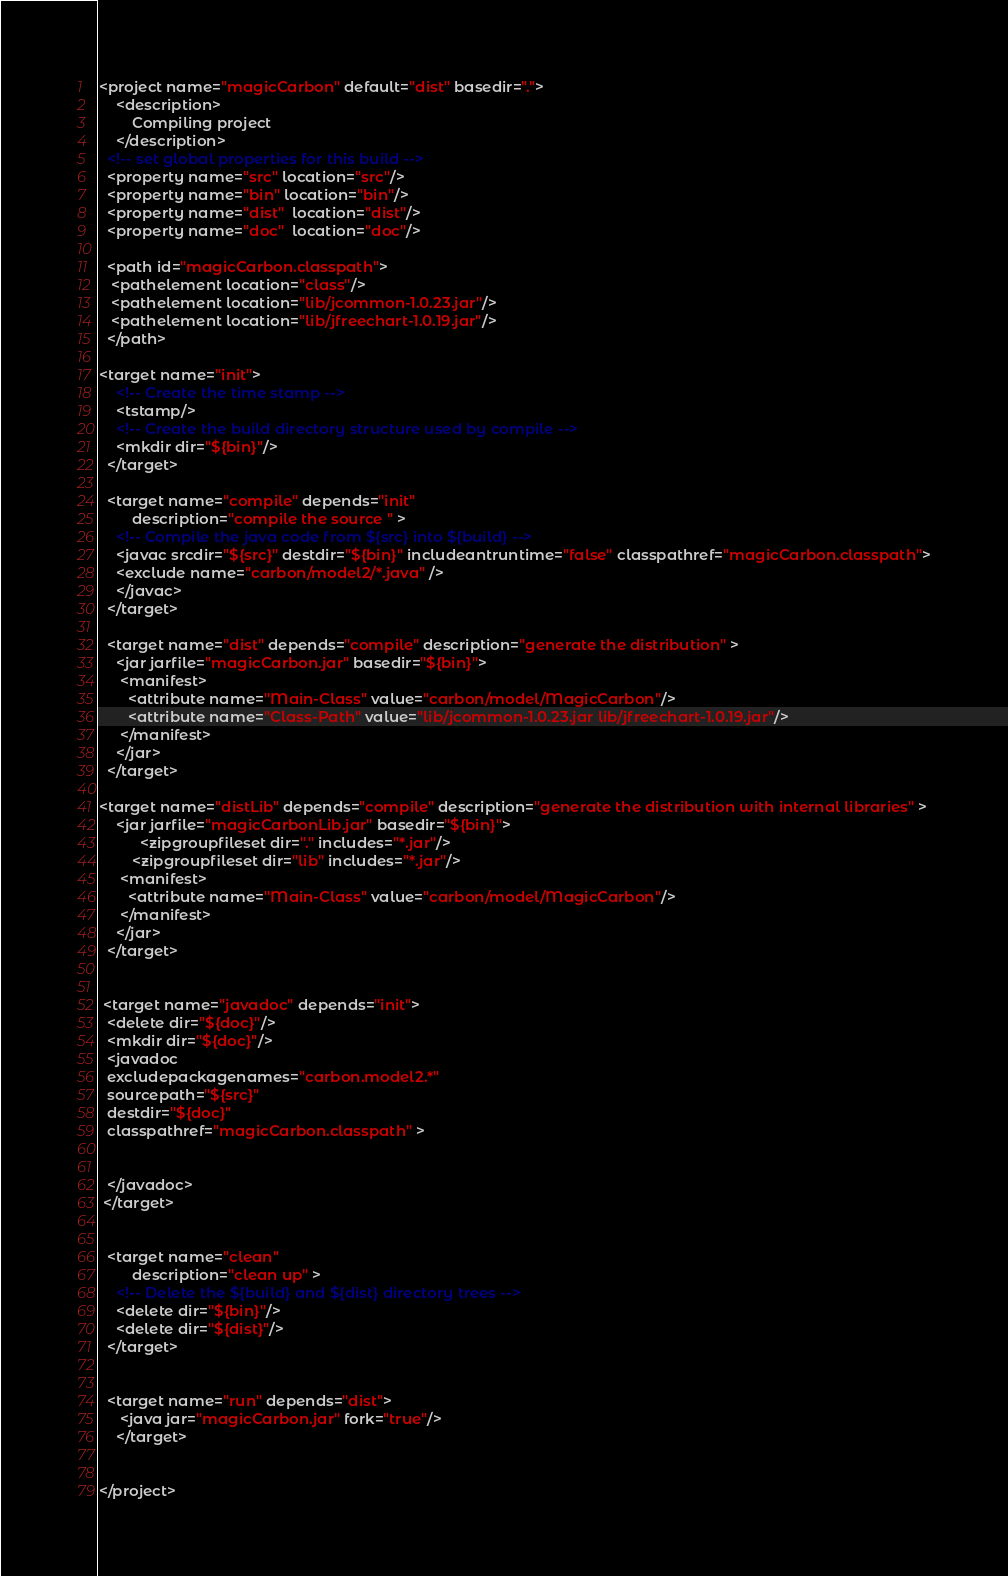Convert code to text. <code><loc_0><loc_0><loc_500><loc_500><_XML_><project name="magicCarbon" default="dist" basedir=".">
    <description>
        Compiling project
    </description>
  <!-- set global properties for this build -->
  <property name="src" location="src"/>
  <property name="bin" location="bin"/>
  <property name="dist"  location="dist"/>
  <property name="doc"  location="doc"/>  
    
  <path id="magicCarbon.classpath">
   <pathelement location="class"/>
   <pathelement location="lib/jcommon-1.0.23.jar"/>
   <pathelement location="lib/jfreechart-1.0.19.jar"/>
  </path>
  
<target name="init">
    <!-- Create the time stamp -->
    <tstamp/>
    <!-- Create the build directory structure used by compile -->
    <mkdir dir="${bin}"/>
  </target>

  <target name="compile" depends="init"
        description="compile the source " >
    <!-- Compile the java code from ${src} into ${build} -->
    <javac srcdir="${src}" destdir="${bin}" includeantruntime="false" classpathref="magicCarbon.classpath">
    <exclude name="carbon/model2/*.java" />
    </javac> 
  </target>

  <target name="dist" depends="compile" description="generate the distribution" >
    <jar jarfile="magicCarbon.jar" basedir="${bin}">
     <manifest>
       <attribute name="Main-Class" value="carbon/model/MagicCarbon"/>
       <attribute name="Class-Path" value="lib/jcommon-1.0.23.jar lib/jfreechart-1.0.19.jar"/>
     </manifest> 
    </jar>
  </target>

<target name="distLib" depends="compile" description="generate the distribution with internal libraries" >
    <jar jarfile="magicCarbonLib.jar" basedir="${bin}">
          <zipgroupfileset dir="." includes="*.jar"/>
        <zipgroupfileset dir="lib" includes="*.jar"/>
     <manifest>
       <attribute name="Main-Class" value="carbon/model/MagicCarbon"/>
     </manifest> 
    </jar>
  </target>


 <target name="javadoc" depends="init">
  <delete dir="${doc}"/>
  <mkdir dir="${doc}"/>
  <javadoc
  excludepackagenames="carbon.model2.*"
  sourcepath="${src}"
  destdir="${doc}"
  classpathref="magicCarbon.classpath" >

 
  </javadoc>
 </target>


  <target name="clean"
        description="clean up" >
    <!-- Delete the ${build} and ${dist} directory trees -->
    <delete dir="${bin}"/>
    <delete dir="${dist}"/>
  </target>


  <target name="run" depends="dist">
     <java jar="magicCarbon.jar" fork="true"/>
    </target>


</project>
</code> 